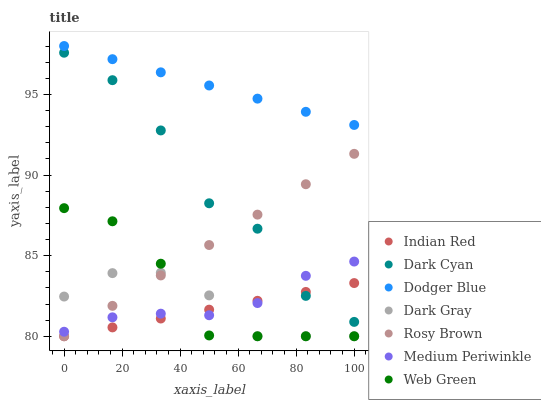Does Indian Red have the minimum area under the curve?
Answer yes or no. Yes. Does Dodger Blue have the maximum area under the curve?
Answer yes or no. Yes. Does Medium Periwinkle have the minimum area under the curve?
Answer yes or no. No. Does Medium Periwinkle have the maximum area under the curve?
Answer yes or no. No. Is Dodger Blue the smoothest?
Answer yes or no. Yes. Is Dark Cyan the roughest?
Answer yes or no. Yes. Is Medium Periwinkle the smoothest?
Answer yes or no. No. Is Medium Periwinkle the roughest?
Answer yes or no. No. Does Rosy Brown have the lowest value?
Answer yes or no. Yes. Does Medium Periwinkle have the lowest value?
Answer yes or no. No. Does Dodger Blue have the highest value?
Answer yes or no. Yes. Does Medium Periwinkle have the highest value?
Answer yes or no. No. Is Medium Periwinkle less than Dodger Blue?
Answer yes or no. Yes. Is Dodger Blue greater than Indian Red?
Answer yes or no. Yes. Does Dark Gray intersect Web Green?
Answer yes or no. Yes. Is Dark Gray less than Web Green?
Answer yes or no. No. Is Dark Gray greater than Web Green?
Answer yes or no. No. Does Medium Periwinkle intersect Dodger Blue?
Answer yes or no. No. 